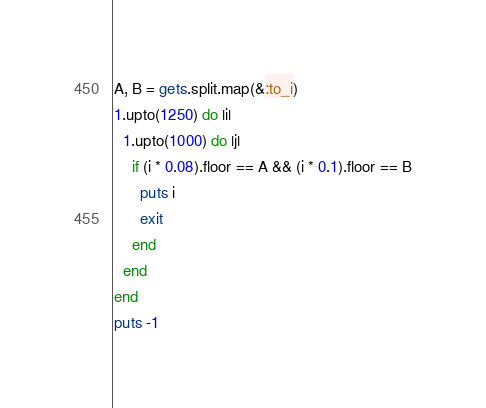<code> <loc_0><loc_0><loc_500><loc_500><_Ruby_>A, B = gets.split.map(&:to_i)
1.upto(1250) do |i|
  1.upto(1000) do |j|
    if (i * 0.08).floor == A && (i * 0.1).floor == B
      puts i
      exit
    end
  end
end
puts -1</code> 